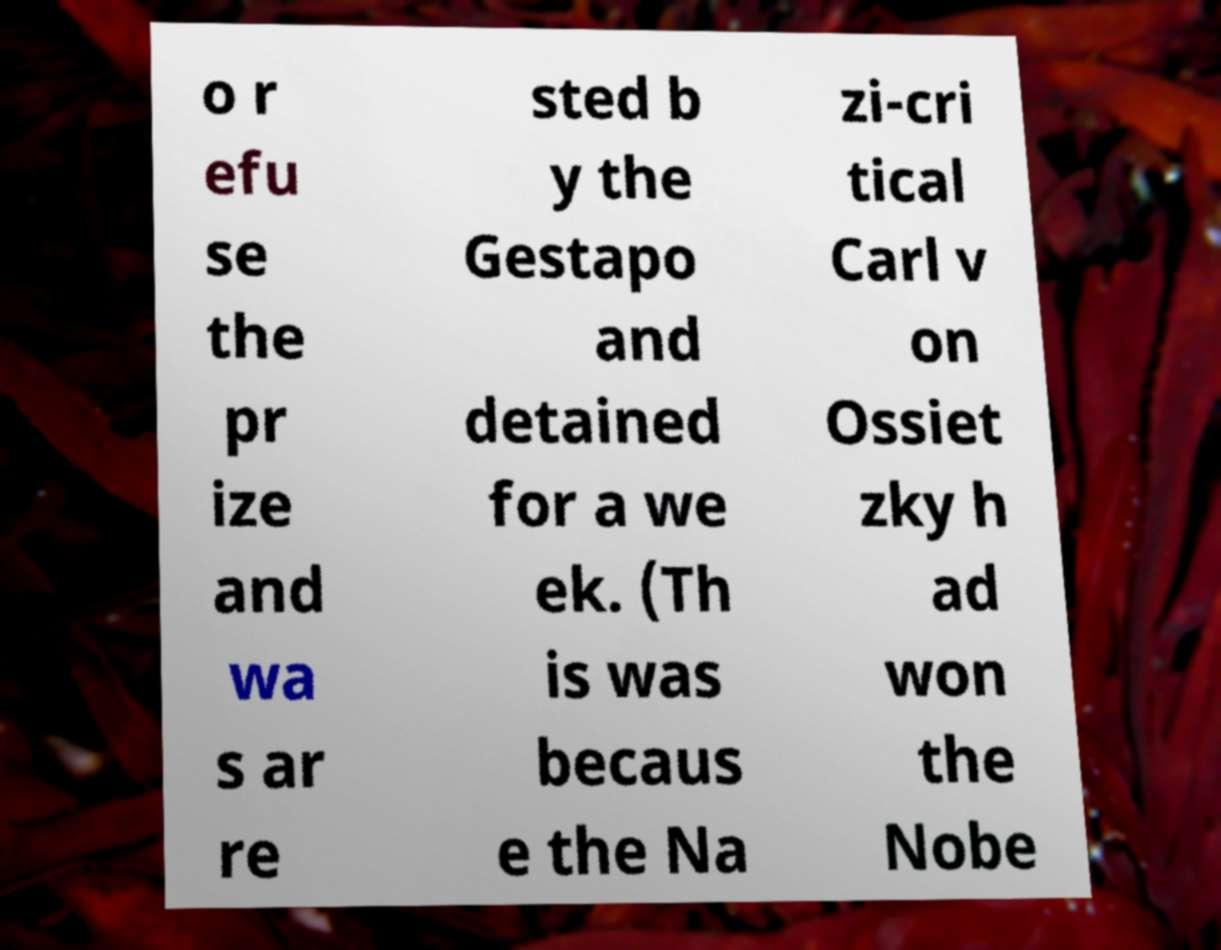What messages or text are displayed in this image? I need them in a readable, typed format. o r efu se the pr ize and wa s ar re sted b y the Gestapo and detained for a we ek. (Th is was becaus e the Na zi-cri tical Carl v on Ossiet zky h ad won the Nobe 